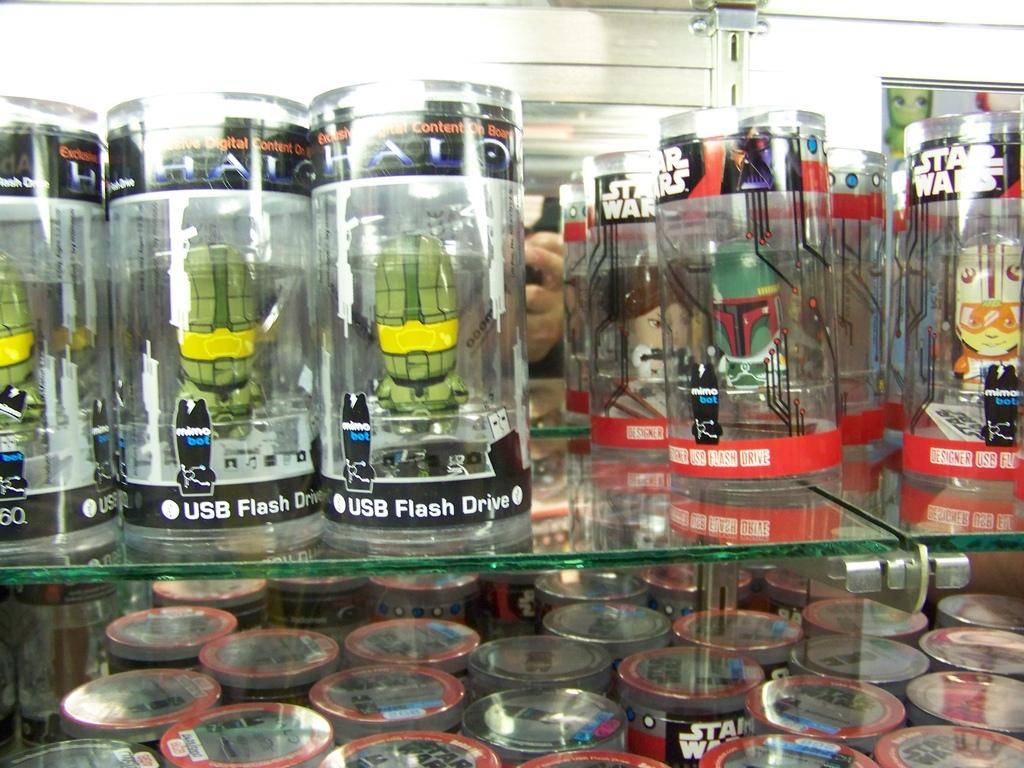<image>
Render a clear and concise summary of the photo. USB flash drives in clear plastic cylinders are lined up on glass shelves. 